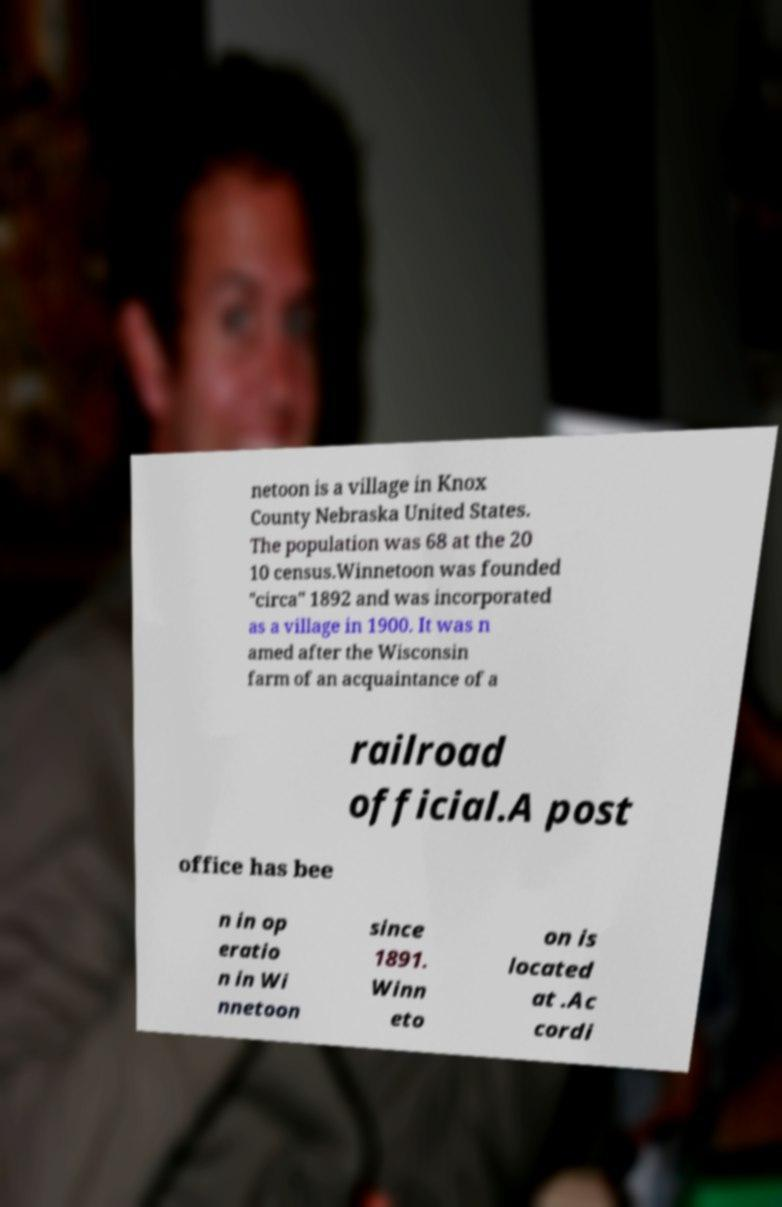Please read and relay the text visible in this image. What does it say? netoon is a village in Knox County Nebraska United States. The population was 68 at the 20 10 census.Winnetoon was founded "circa" 1892 and was incorporated as a village in 1900. It was n amed after the Wisconsin farm of an acquaintance of a railroad official.A post office has bee n in op eratio n in Wi nnetoon since 1891. Winn eto on is located at .Ac cordi 